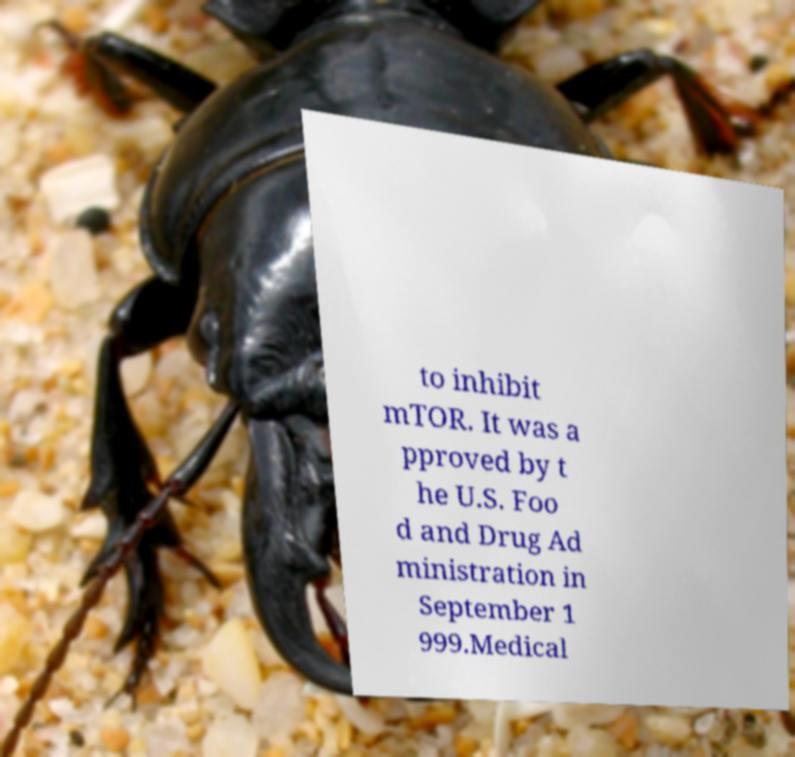Can you read and provide the text displayed in the image?This photo seems to have some interesting text. Can you extract and type it out for me? to inhibit mTOR. It was a pproved by t he U.S. Foo d and Drug Ad ministration in September 1 999.Medical 